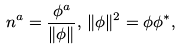<formula> <loc_0><loc_0><loc_500><loc_500>n ^ { a } = \frac { \phi ^ { a } } { \| \phi \| } , \, \| \phi \| ^ { 2 } = \phi \phi ^ { * } ,</formula> 